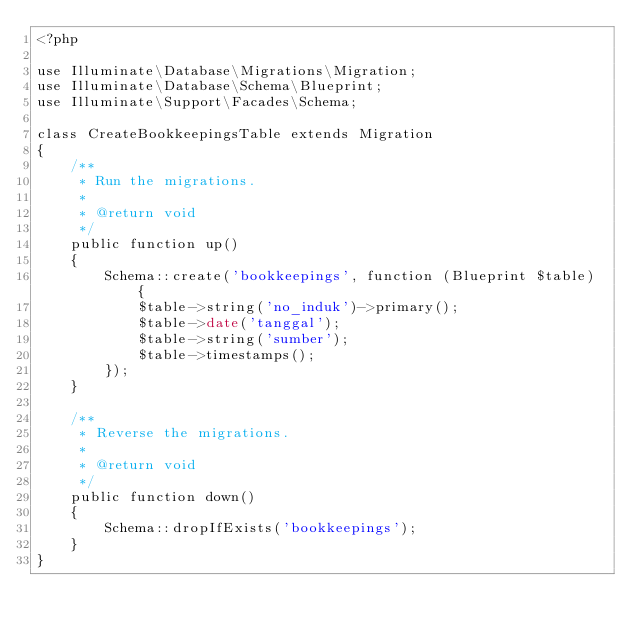<code> <loc_0><loc_0><loc_500><loc_500><_PHP_><?php

use Illuminate\Database\Migrations\Migration;
use Illuminate\Database\Schema\Blueprint;
use Illuminate\Support\Facades\Schema;

class CreateBookkeepingsTable extends Migration
{
    /**
     * Run the migrations.
     *
     * @return void
     */
    public function up()
    {
        Schema::create('bookkeepings', function (Blueprint $table) {
            $table->string('no_induk')->primary();
            $table->date('tanggal');
            $table->string('sumber');
            $table->timestamps();
        });
    }

    /**
     * Reverse the migrations.
     *
     * @return void
     */
    public function down()
    {
        Schema::dropIfExists('bookkeepings');
    }
}
</code> 